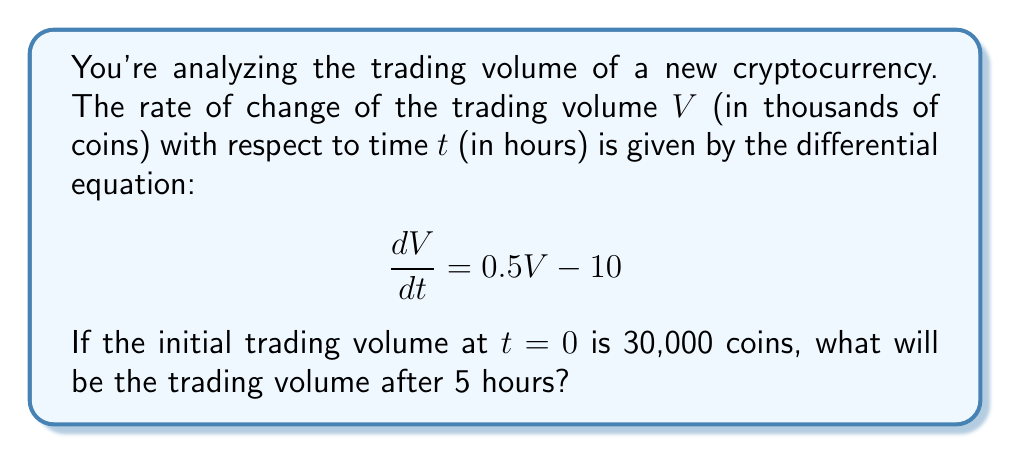Give your solution to this math problem. Let's solve this problem step by step:

1) We have a first-order linear differential equation:

   $$\frac{dV}{dt} = 0.5V - 10$$

2) This is in the form $\frac{dV}{dt} + P(t)V = Q(t)$, where $P(t) = -0.5$ and $Q(t) = 10$.

3) The general solution for this type of equation is:

   $$V = e^{-\int P(t)dt} \left(\int Q(t)e^{\int P(t)dt}dt + C\right)$$

4) Let's solve it:
   
   $$\int P(t)dt = \int -0.5dt = -0.5t$$
   
   $$e^{\int P(t)dt} = e^{-0.5t}$$

5) Now, let's find $\int Q(t)e^{\int P(t)dt}dt$:

   $$\int 10e^{-0.5t}dt = -20e^{-0.5t} + C_1$$

6) Substituting back into the general solution:

   $$V = e^{0.5t}(-20e^{-0.5t} + C_1) = -20 + Ce^{0.5t}$$

   where $C = C_1e^{0.5t}$

7) Now, we use the initial condition: At $t=0$, $V=30$ (remember, V is in thousands)

   $$30 = -20 + C$$
   $$C = 50$$

8) So our particular solution is:

   $$V = -20 + 50e^{0.5t}$$

9) To find the volume after 5 hours, we substitute $t=5$:

   $$V = -20 + 50e^{0.5(5)} = -20 + 50e^{2.5} \approx 283.68$$

10) Remember to convert back to actual number of coins by multiplying by 1000.
Answer: The trading volume after 5 hours will be approximately 283,680 coins. 